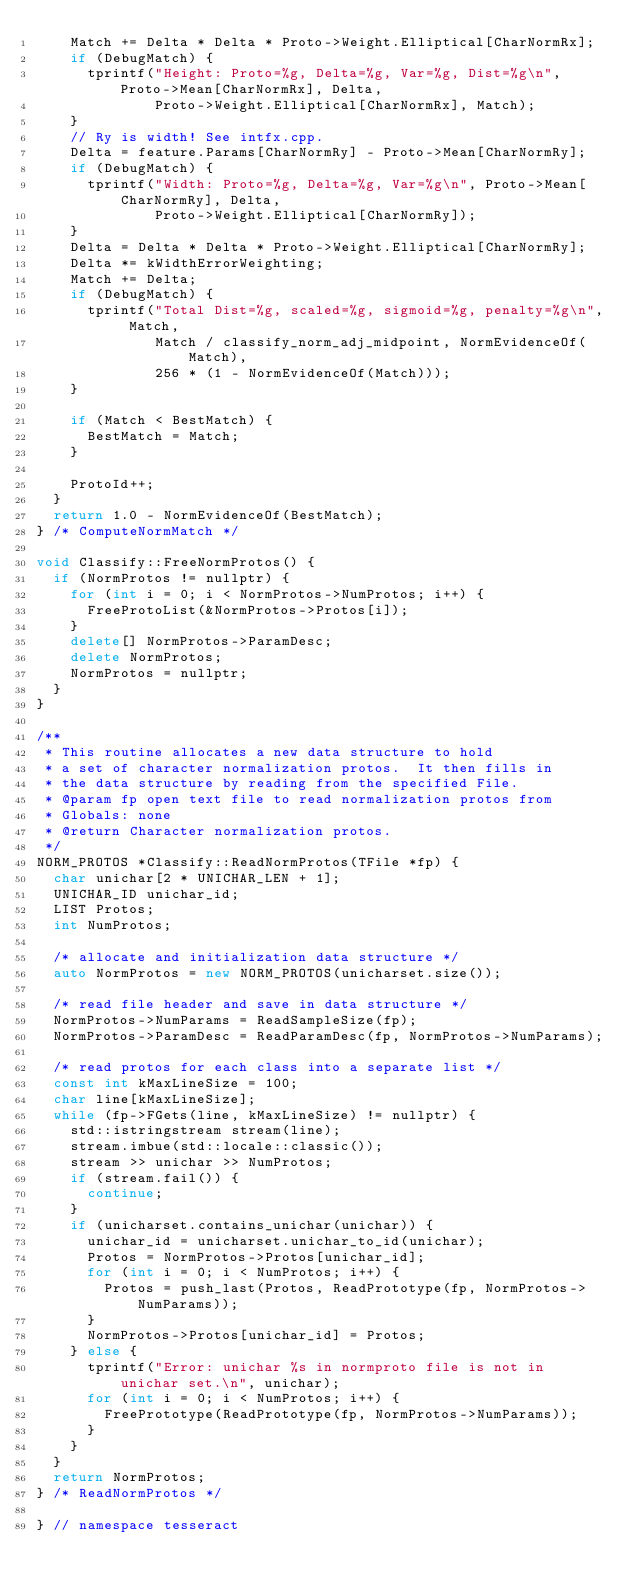Convert code to text. <code><loc_0><loc_0><loc_500><loc_500><_C++_>    Match += Delta * Delta * Proto->Weight.Elliptical[CharNormRx];
    if (DebugMatch) {
      tprintf("Height: Proto=%g, Delta=%g, Var=%g, Dist=%g\n", Proto->Mean[CharNormRx], Delta,
              Proto->Weight.Elliptical[CharNormRx], Match);
    }
    // Ry is width! See intfx.cpp.
    Delta = feature.Params[CharNormRy] - Proto->Mean[CharNormRy];
    if (DebugMatch) {
      tprintf("Width: Proto=%g, Delta=%g, Var=%g\n", Proto->Mean[CharNormRy], Delta,
              Proto->Weight.Elliptical[CharNormRy]);
    }
    Delta = Delta * Delta * Proto->Weight.Elliptical[CharNormRy];
    Delta *= kWidthErrorWeighting;
    Match += Delta;
    if (DebugMatch) {
      tprintf("Total Dist=%g, scaled=%g, sigmoid=%g, penalty=%g\n", Match,
              Match / classify_norm_adj_midpoint, NormEvidenceOf(Match),
              256 * (1 - NormEvidenceOf(Match)));
    }

    if (Match < BestMatch) {
      BestMatch = Match;
    }

    ProtoId++;
  }
  return 1.0 - NormEvidenceOf(BestMatch);
} /* ComputeNormMatch */

void Classify::FreeNormProtos() {
  if (NormProtos != nullptr) {
    for (int i = 0; i < NormProtos->NumProtos; i++) {
      FreeProtoList(&NormProtos->Protos[i]);
    }
    delete[] NormProtos->ParamDesc;
    delete NormProtos;
    NormProtos = nullptr;
  }
}

/**
 * This routine allocates a new data structure to hold
 * a set of character normalization protos.  It then fills in
 * the data structure by reading from the specified File.
 * @param fp open text file to read normalization protos from
 * Globals: none
 * @return Character normalization protos.
 */
NORM_PROTOS *Classify::ReadNormProtos(TFile *fp) {
  char unichar[2 * UNICHAR_LEN + 1];
  UNICHAR_ID unichar_id;
  LIST Protos;
  int NumProtos;

  /* allocate and initialization data structure */
  auto NormProtos = new NORM_PROTOS(unicharset.size());

  /* read file header and save in data structure */
  NormProtos->NumParams = ReadSampleSize(fp);
  NormProtos->ParamDesc = ReadParamDesc(fp, NormProtos->NumParams);

  /* read protos for each class into a separate list */
  const int kMaxLineSize = 100;
  char line[kMaxLineSize];
  while (fp->FGets(line, kMaxLineSize) != nullptr) {
    std::istringstream stream(line);
    stream.imbue(std::locale::classic());
    stream >> unichar >> NumProtos;
    if (stream.fail()) {
      continue;
    }
    if (unicharset.contains_unichar(unichar)) {
      unichar_id = unicharset.unichar_to_id(unichar);
      Protos = NormProtos->Protos[unichar_id];
      for (int i = 0; i < NumProtos; i++) {
        Protos = push_last(Protos, ReadPrototype(fp, NormProtos->NumParams));
      }
      NormProtos->Protos[unichar_id] = Protos;
    } else {
      tprintf("Error: unichar %s in normproto file is not in unichar set.\n", unichar);
      for (int i = 0; i < NumProtos; i++) {
        FreePrototype(ReadPrototype(fp, NormProtos->NumParams));
      }
    }
  }
  return NormProtos;
} /* ReadNormProtos */

} // namespace tesseract
</code> 